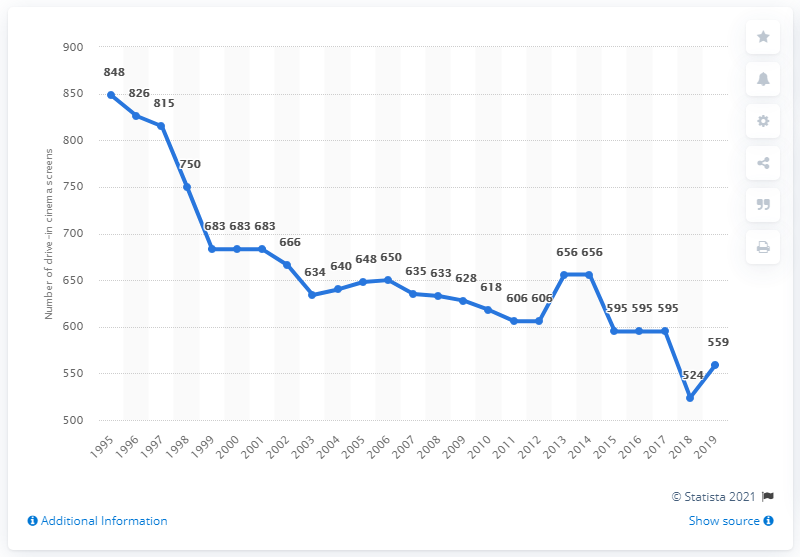Highlight a few significant elements in this photo. In 2019, there were 559 drive-in cinema screens in the United States. The average of the last three years is 559. The line graph depicts the number of drive-in cinema screens in the y-axis. 